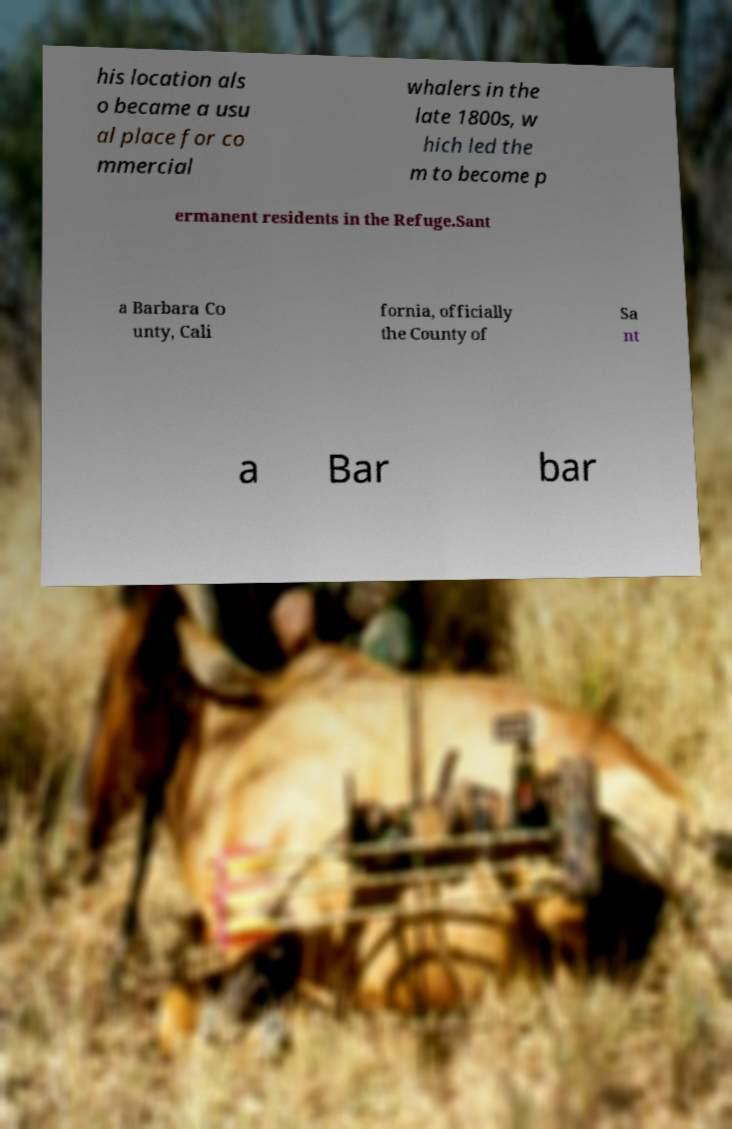Can you accurately transcribe the text from the provided image for me? his location als o became a usu al place for co mmercial whalers in the late 1800s, w hich led the m to become p ermanent residents in the Refuge.Sant a Barbara Co unty, Cali fornia, officially the County of Sa nt a Bar bar 